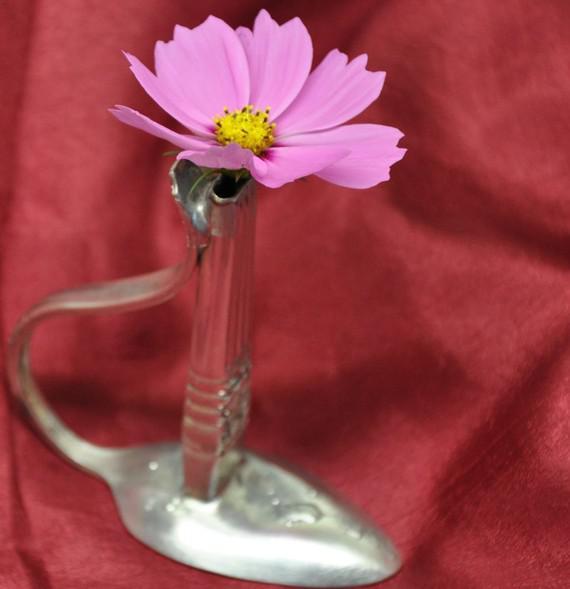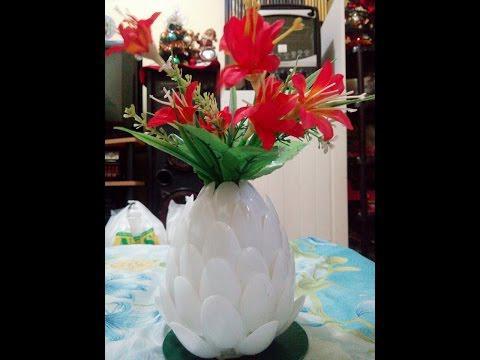The first image is the image on the left, the second image is the image on the right. Evaluate the accuracy of this statement regarding the images: "In one image the object rests on a tablecloth and in the other image it rests on bare wood.". Is it true? Answer yes or no. No. The first image is the image on the left, the second image is the image on the right. Given the left and right images, does the statement "An image shows a white vase resembling an artichoke, filled with red lily-type flowers and sitting on a table." hold true? Answer yes or no. Yes. 